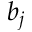Convert formula to latex. <formula><loc_0><loc_0><loc_500><loc_500>b _ { j }</formula> 